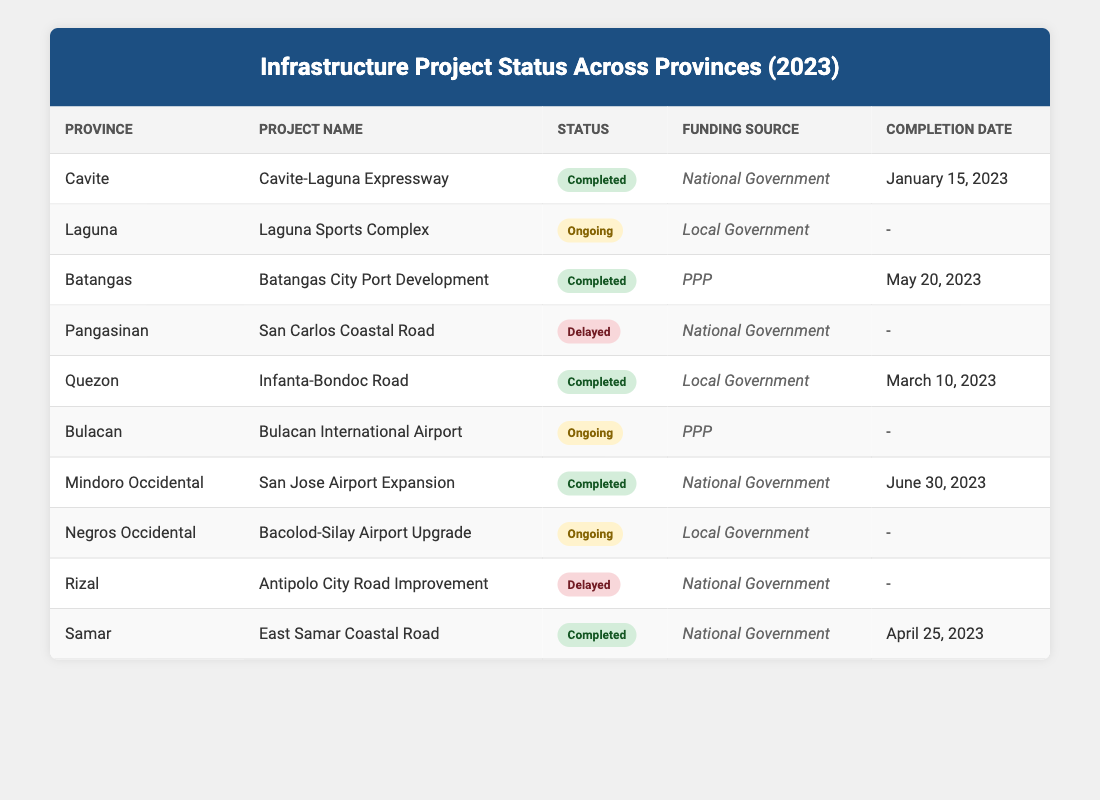What is the completion status of the Cavite-Laguna Expressway project? The table indicates that the completion status of the Cavite-Laguna Expressway project, located in Cavite, is "Completed."
Answer: Completed How many infrastructure projects have a completion status of "Ongoing"? There are three ongoing projects listed: Laguna Sports Complex in Laguna, Bulacan International Airport in Bulacan, and Bacolod-Silay Airport Upgrade in Negros Occidental, making a total of three ongoing projects.
Answer: Three Which province has the infrastructure project "Infanta-Bondoc Road"? The table shows that the Infanta-Bondoc Road project is located in Quezon province.
Answer: Quezon Is the funding source for the Batangas City Port Development project a Public-Private Partnership (PPP)? Yes, the funding source for the Batangas City Port Development project is listed as PPP, according to the table.
Answer: Yes What is the completion date of the San Jose Airport Expansion project? The San Jose Airport Expansion project in Mindoro Occidental has a completion date of June 30, 2023, as per the table.
Answer: June 30, 2023 How many projects are delayed across all provinces? There are two delayed projects: San Carlos Coastal Road in Pangasinan and Antipolo City Road Improvement in Rizal, totaling two delayed projects in the table.
Answer: Two Which project was completed the earliest in 2023? The Cavite-Laguna Expressway project, completed on January 15, 2023, is the earliest completed project in the table.
Answer: January 15, 2023 What percentage of total projects is completed? Out of the ten projects, five are completed. Therefore, (5/10) * 100% = 50% of the projects are completed.
Answer: 50% How many projects are funded by the National Government? The projects funded by the National Government are Cavite-Laguna Expressway, San Carlos Coastal Road, San Jose Airport Expansion, and East Samar Coastal Road, totaling four projects.
Answer: Four 